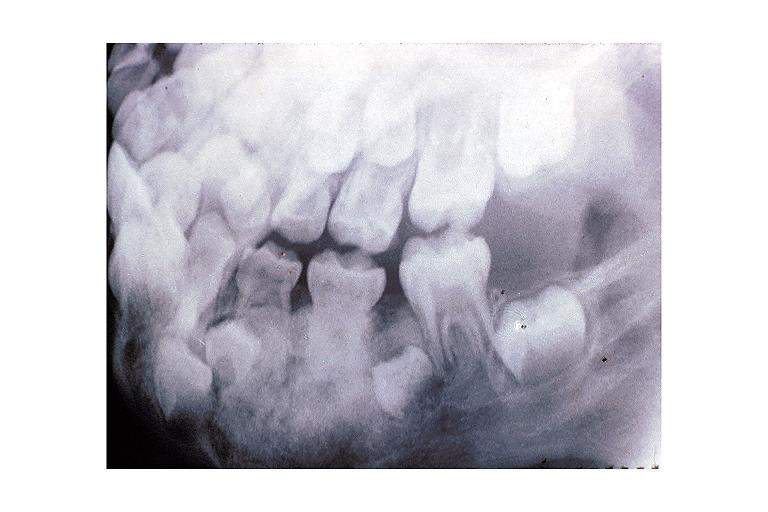does this image show osteoblastoma?
Answer the question using a single word or phrase. Yes 